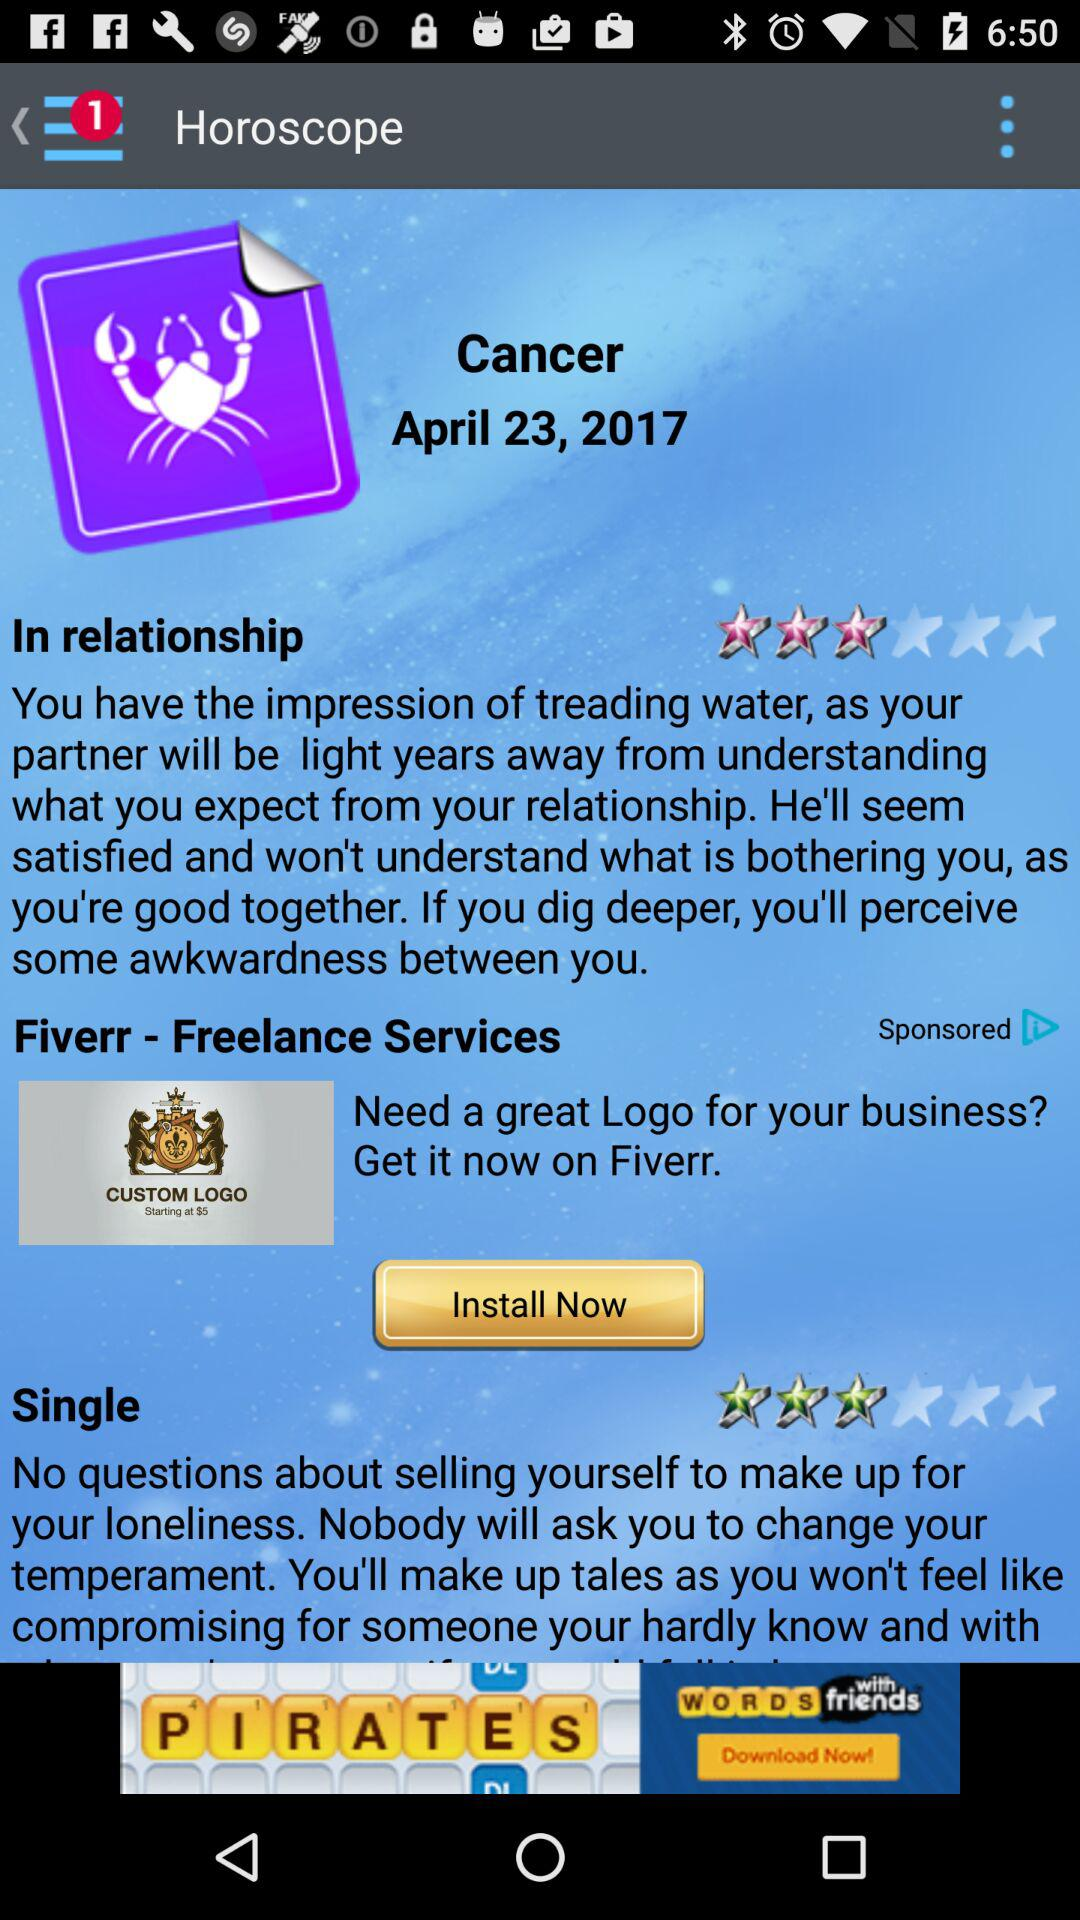What is the date? The date is 23rd April, 2017. 